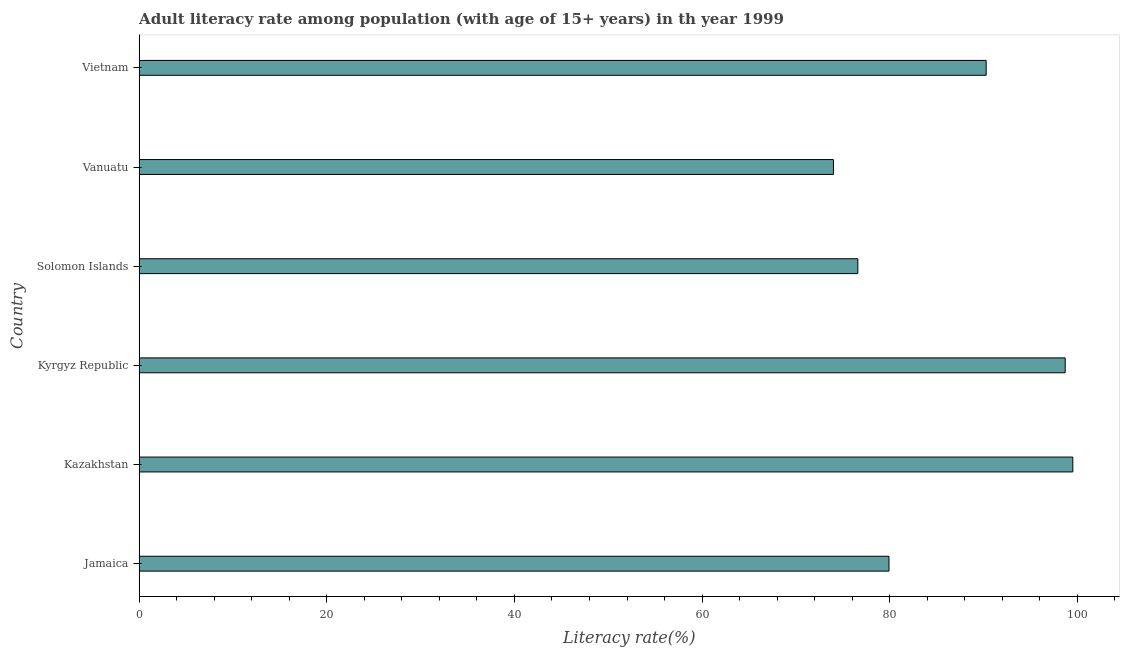Does the graph contain any zero values?
Make the answer very short. No. What is the title of the graph?
Make the answer very short. Adult literacy rate among population (with age of 15+ years) in th year 1999. What is the label or title of the X-axis?
Give a very brief answer. Literacy rate(%). What is the adult literacy rate in Kyrgyz Republic?
Give a very brief answer. 98.7. Across all countries, what is the maximum adult literacy rate?
Provide a succinct answer. 99.51. Across all countries, what is the minimum adult literacy rate?
Give a very brief answer. 74. In which country was the adult literacy rate maximum?
Your answer should be very brief. Kazakhstan. In which country was the adult literacy rate minimum?
Your answer should be compact. Vanuatu. What is the sum of the adult literacy rate?
Offer a terse response. 519.01. What is the difference between the adult literacy rate in Vanuatu and Vietnam?
Ensure brevity in your answer.  -16.28. What is the average adult literacy rate per country?
Your response must be concise. 86.5. What is the median adult literacy rate?
Make the answer very short. 85.1. What is the ratio of the adult literacy rate in Kazakhstan to that in Kyrgyz Republic?
Your answer should be very brief. 1.01. Is the difference between the adult literacy rate in Solomon Islands and Vanuatu greater than the difference between any two countries?
Provide a succinct answer. No. What is the difference between the highest and the second highest adult literacy rate?
Give a very brief answer. 0.81. Is the sum of the adult literacy rate in Kyrgyz Republic and Vietnam greater than the maximum adult literacy rate across all countries?
Offer a terse response. Yes. What is the difference between the highest and the lowest adult literacy rate?
Keep it short and to the point. 25.51. In how many countries, is the adult literacy rate greater than the average adult literacy rate taken over all countries?
Give a very brief answer. 3. What is the difference between two consecutive major ticks on the X-axis?
Offer a terse response. 20. What is the Literacy rate(%) in Jamaica?
Your answer should be very brief. 79.92. What is the Literacy rate(%) of Kazakhstan?
Offer a terse response. 99.51. What is the Literacy rate(%) in Kyrgyz Republic?
Provide a short and direct response. 98.7. What is the Literacy rate(%) in Solomon Islands?
Provide a short and direct response. 76.6. What is the Literacy rate(%) of Vietnam?
Your answer should be compact. 90.28. What is the difference between the Literacy rate(%) in Jamaica and Kazakhstan?
Give a very brief answer. -19.59. What is the difference between the Literacy rate(%) in Jamaica and Kyrgyz Republic?
Make the answer very short. -18.78. What is the difference between the Literacy rate(%) in Jamaica and Solomon Islands?
Make the answer very short. 3.32. What is the difference between the Literacy rate(%) in Jamaica and Vanuatu?
Ensure brevity in your answer.  5.92. What is the difference between the Literacy rate(%) in Jamaica and Vietnam?
Your response must be concise. -10.36. What is the difference between the Literacy rate(%) in Kazakhstan and Kyrgyz Republic?
Offer a terse response. 0.81. What is the difference between the Literacy rate(%) in Kazakhstan and Solomon Islands?
Keep it short and to the point. 22.91. What is the difference between the Literacy rate(%) in Kazakhstan and Vanuatu?
Offer a terse response. 25.51. What is the difference between the Literacy rate(%) in Kazakhstan and Vietnam?
Your answer should be compact. 9.23. What is the difference between the Literacy rate(%) in Kyrgyz Republic and Solomon Islands?
Your response must be concise. 22.1. What is the difference between the Literacy rate(%) in Kyrgyz Republic and Vanuatu?
Your answer should be very brief. 24.7. What is the difference between the Literacy rate(%) in Kyrgyz Republic and Vietnam?
Offer a very short reply. 8.42. What is the difference between the Literacy rate(%) in Solomon Islands and Vietnam?
Make the answer very short. -13.68. What is the difference between the Literacy rate(%) in Vanuatu and Vietnam?
Give a very brief answer. -16.28. What is the ratio of the Literacy rate(%) in Jamaica to that in Kazakhstan?
Provide a succinct answer. 0.8. What is the ratio of the Literacy rate(%) in Jamaica to that in Kyrgyz Republic?
Make the answer very short. 0.81. What is the ratio of the Literacy rate(%) in Jamaica to that in Solomon Islands?
Keep it short and to the point. 1.04. What is the ratio of the Literacy rate(%) in Jamaica to that in Vanuatu?
Your answer should be very brief. 1.08. What is the ratio of the Literacy rate(%) in Jamaica to that in Vietnam?
Your answer should be very brief. 0.89. What is the ratio of the Literacy rate(%) in Kazakhstan to that in Solomon Islands?
Offer a very short reply. 1.3. What is the ratio of the Literacy rate(%) in Kazakhstan to that in Vanuatu?
Keep it short and to the point. 1.34. What is the ratio of the Literacy rate(%) in Kazakhstan to that in Vietnam?
Keep it short and to the point. 1.1. What is the ratio of the Literacy rate(%) in Kyrgyz Republic to that in Solomon Islands?
Ensure brevity in your answer.  1.29. What is the ratio of the Literacy rate(%) in Kyrgyz Republic to that in Vanuatu?
Provide a succinct answer. 1.33. What is the ratio of the Literacy rate(%) in Kyrgyz Republic to that in Vietnam?
Give a very brief answer. 1.09. What is the ratio of the Literacy rate(%) in Solomon Islands to that in Vanuatu?
Offer a terse response. 1.03. What is the ratio of the Literacy rate(%) in Solomon Islands to that in Vietnam?
Provide a succinct answer. 0.85. What is the ratio of the Literacy rate(%) in Vanuatu to that in Vietnam?
Make the answer very short. 0.82. 